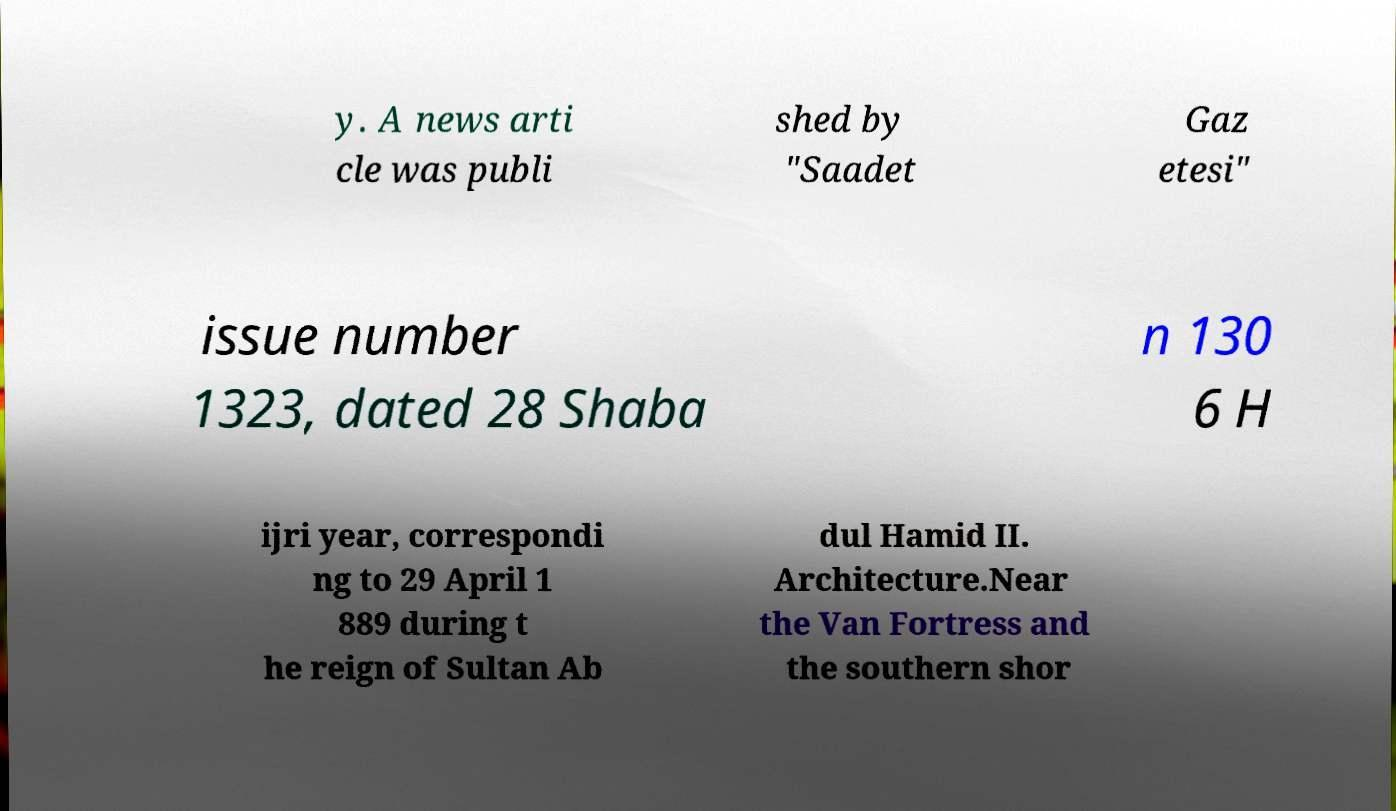Could you assist in decoding the text presented in this image and type it out clearly? y. A news arti cle was publi shed by "Saadet Gaz etesi" issue number 1323, dated 28 Shaba n 130 6 H ijri year, correspondi ng to 29 April 1 889 during t he reign of Sultan Ab dul Hamid II. Architecture.Near the Van Fortress and the southern shor 